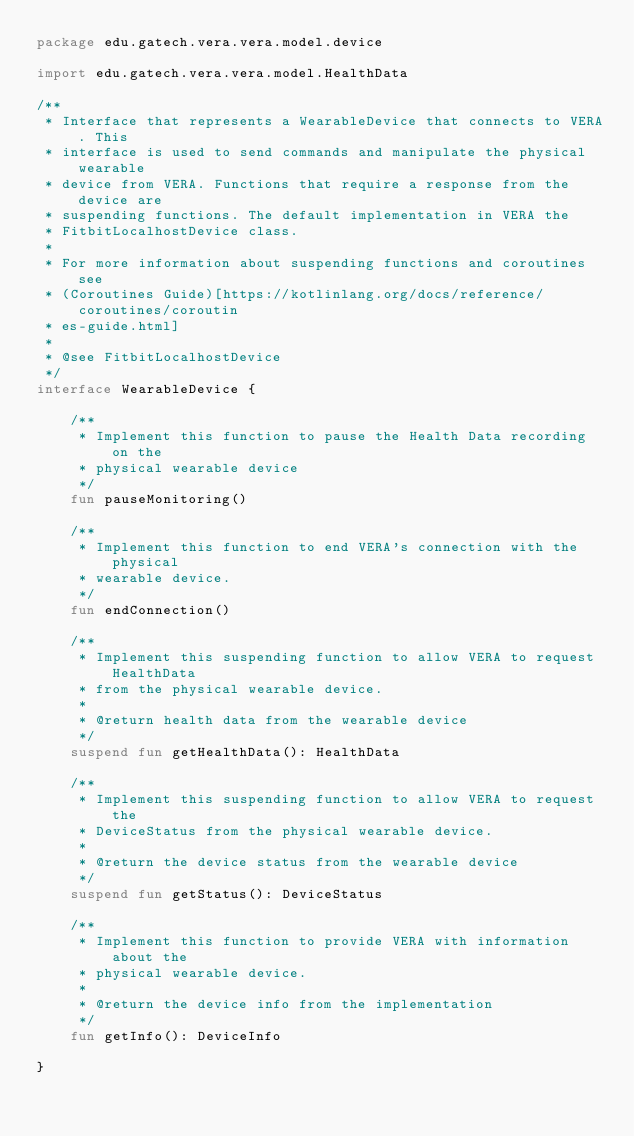<code> <loc_0><loc_0><loc_500><loc_500><_Kotlin_>package edu.gatech.vera.vera.model.device

import edu.gatech.vera.vera.model.HealthData

/**
 * Interface that represents a WearableDevice that connects to VERA. This
 * interface is used to send commands and manipulate the physical wearable
 * device from VERA. Functions that require a response from the device are
 * suspending functions. The default implementation in VERA the
 * FitbitLocalhostDevice class.
 *
 * For more information about suspending functions and coroutines see
 * (Coroutines Guide)[https://kotlinlang.org/docs/reference/coroutines/coroutin
 * es-guide.html]
 *
 * @see FitbitLocalhostDevice
 */
interface WearableDevice {

    /**
     * Implement this function to pause the Health Data recording on the
     * physical wearable device
     */
    fun pauseMonitoring()

    /**
     * Implement this function to end VERA's connection with the physical
     * wearable device.
     */
    fun endConnection()

    /**
     * Implement this suspending function to allow VERA to request HealthData
     * from the physical wearable device.
     *
     * @return health data from the wearable device
     */
    suspend fun getHealthData(): HealthData

    /**
     * Implement this suspending function to allow VERA to request the
     * DeviceStatus from the physical wearable device.
     *
     * @return the device status from the wearable device
     */
    suspend fun getStatus(): DeviceStatus

    /**
     * Implement this function to provide VERA with information about the
     * physical wearable device.
     *
     * @return the device info from the implementation
     */
    fun getInfo(): DeviceInfo

}</code> 